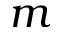<formula> <loc_0><loc_0><loc_500><loc_500>m</formula> 